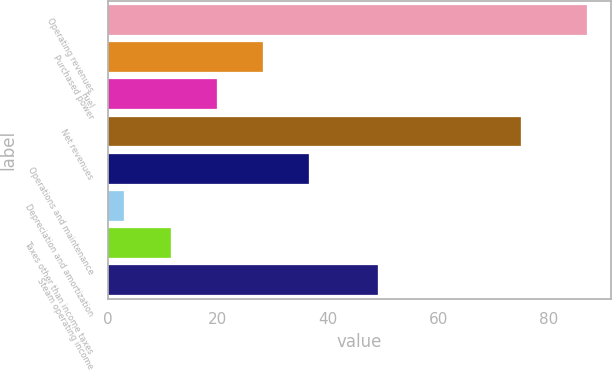Convert chart to OTSL. <chart><loc_0><loc_0><loc_500><loc_500><bar_chart><fcel>Operating revenues<fcel>Purchased power<fcel>Fuel<fcel>Net revenues<fcel>Operations and maintenance<fcel>Depreciation and amortization<fcel>Taxes other than income taxes<fcel>Steam operating income<nl><fcel>87<fcel>28.2<fcel>19.8<fcel>75<fcel>36.6<fcel>3<fcel>11.4<fcel>49<nl></chart> 